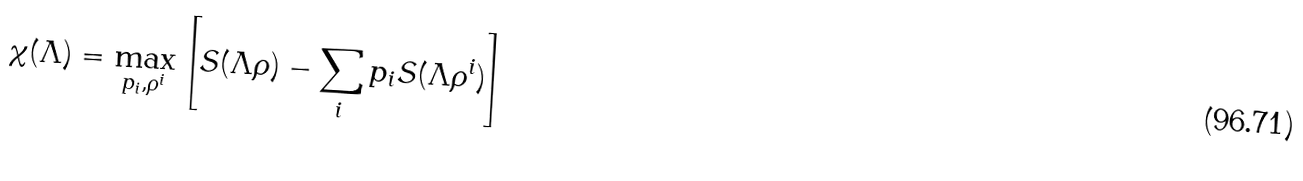Convert formula to latex. <formula><loc_0><loc_0><loc_500><loc_500>\chi ( \Lambda ) = \max _ { p _ { i } , \rho ^ { i } } \left [ S ( \Lambda \rho ) - \sum _ { i } p _ { i } S ( \Lambda \rho ^ { i } ) \right ]</formula> 